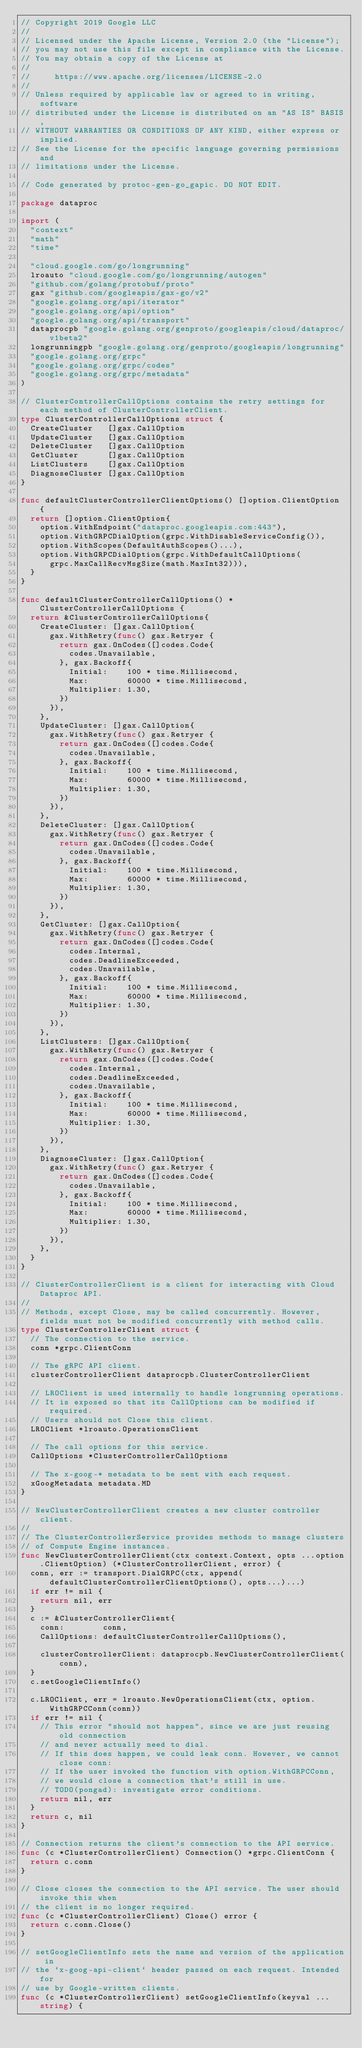Convert code to text. <code><loc_0><loc_0><loc_500><loc_500><_Go_>// Copyright 2019 Google LLC
//
// Licensed under the Apache License, Version 2.0 (the "License");
// you may not use this file except in compliance with the License.
// You may obtain a copy of the License at
//
//     https://www.apache.org/licenses/LICENSE-2.0
//
// Unless required by applicable law or agreed to in writing, software
// distributed under the License is distributed on an "AS IS" BASIS,
// WITHOUT WARRANTIES OR CONDITIONS OF ANY KIND, either express or implied.
// See the License for the specific language governing permissions and
// limitations under the License.

// Code generated by protoc-gen-go_gapic. DO NOT EDIT.

package dataproc

import (
	"context"
	"math"
	"time"

	"cloud.google.com/go/longrunning"
	lroauto "cloud.google.com/go/longrunning/autogen"
	"github.com/golang/protobuf/proto"
	gax "github.com/googleapis/gax-go/v2"
	"google.golang.org/api/iterator"
	"google.golang.org/api/option"
	"google.golang.org/api/transport"
	dataprocpb "google.golang.org/genproto/googleapis/cloud/dataproc/v1beta2"
	longrunningpb "google.golang.org/genproto/googleapis/longrunning"
	"google.golang.org/grpc"
	"google.golang.org/grpc/codes"
	"google.golang.org/grpc/metadata"
)

// ClusterControllerCallOptions contains the retry settings for each method of ClusterControllerClient.
type ClusterControllerCallOptions struct {
	CreateCluster   []gax.CallOption
	UpdateCluster   []gax.CallOption
	DeleteCluster   []gax.CallOption
	GetCluster      []gax.CallOption
	ListClusters    []gax.CallOption
	DiagnoseCluster []gax.CallOption
}

func defaultClusterControllerClientOptions() []option.ClientOption {
	return []option.ClientOption{
		option.WithEndpoint("dataproc.googleapis.com:443"),
		option.WithGRPCDialOption(grpc.WithDisableServiceConfig()),
		option.WithScopes(DefaultAuthScopes()...),
		option.WithGRPCDialOption(grpc.WithDefaultCallOptions(
			grpc.MaxCallRecvMsgSize(math.MaxInt32))),
	}
}

func defaultClusterControllerCallOptions() *ClusterControllerCallOptions {
	return &ClusterControllerCallOptions{
		CreateCluster: []gax.CallOption{
			gax.WithRetry(func() gax.Retryer {
				return gax.OnCodes([]codes.Code{
					codes.Unavailable,
				}, gax.Backoff{
					Initial:    100 * time.Millisecond,
					Max:        60000 * time.Millisecond,
					Multiplier: 1.30,
				})
			}),
		},
		UpdateCluster: []gax.CallOption{
			gax.WithRetry(func() gax.Retryer {
				return gax.OnCodes([]codes.Code{
					codes.Unavailable,
				}, gax.Backoff{
					Initial:    100 * time.Millisecond,
					Max:        60000 * time.Millisecond,
					Multiplier: 1.30,
				})
			}),
		},
		DeleteCluster: []gax.CallOption{
			gax.WithRetry(func() gax.Retryer {
				return gax.OnCodes([]codes.Code{
					codes.Unavailable,
				}, gax.Backoff{
					Initial:    100 * time.Millisecond,
					Max:        60000 * time.Millisecond,
					Multiplier: 1.30,
				})
			}),
		},
		GetCluster: []gax.CallOption{
			gax.WithRetry(func() gax.Retryer {
				return gax.OnCodes([]codes.Code{
					codes.Internal,
					codes.DeadlineExceeded,
					codes.Unavailable,
				}, gax.Backoff{
					Initial:    100 * time.Millisecond,
					Max:        60000 * time.Millisecond,
					Multiplier: 1.30,
				})
			}),
		},
		ListClusters: []gax.CallOption{
			gax.WithRetry(func() gax.Retryer {
				return gax.OnCodes([]codes.Code{
					codes.Internal,
					codes.DeadlineExceeded,
					codes.Unavailable,
				}, gax.Backoff{
					Initial:    100 * time.Millisecond,
					Max:        60000 * time.Millisecond,
					Multiplier: 1.30,
				})
			}),
		},
		DiagnoseCluster: []gax.CallOption{
			gax.WithRetry(func() gax.Retryer {
				return gax.OnCodes([]codes.Code{
					codes.Unavailable,
				}, gax.Backoff{
					Initial:    100 * time.Millisecond,
					Max:        60000 * time.Millisecond,
					Multiplier: 1.30,
				})
			}),
		},
	}
}

// ClusterControllerClient is a client for interacting with Cloud Dataproc API.
//
// Methods, except Close, may be called concurrently. However, fields must not be modified concurrently with method calls.
type ClusterControllerClient struct {
	// The connection to the service.
	conn *grpc.ClientConn

	// The gRPC API client.
	clusterControllerClient dataprocpb.ClusterControllerClient

	// LROClient is used internally to handle longrunning operations.
	// It is exposed so that its CallOptions can be modified if required.
	// Users should not Close this client.
	LROClient *lroauto.OperationsClient

	// The call options for this service.
	CallOptions *ClusterControllerCallOptions

	// The x-goog-* metadata to be sent with each request.
	xGoogMetadata metadata.MD
}

// NewClusterControllerClient creates a new cluster controller client.
//
// The ClusterControllerService provides methods to manage clusters
// of Compute Engine instances.
func NewClusterControllerClient(ctx context.Context, opts ...option.ClientOption) (*ClusterControllerClient, error) {
	conn, err := transport.DialGRPC(ctx, append(defaultClusterControllerClientOptions(), opts...)...)
	if err != nil {
		return nil, err
	}
	c := &ClusterControllerClient{
		conn:        conn,
		CallOptions: defaultClusterControllerCallOptions(),

		clusterControllerClient: dataprocpb.NewClusterControllerClient(conn),
	}
	c.setGoogleClientInfo()

	c.LROClient, err = lroauto.NewOperationsClient(ctx, option.WithGRPCConn(conn))
	if err != nil {
		// This error "should not happen", since we are just reusing old connection
		// and never actually need to dial.
		// If this does happen, we could leak conn. However, we cannot close conn:
		// If the user invoked the function with option.WithGRPCConn,
		// we would close a connection that's still in use.
		// TODO(pongad): investigate error conditions.
		return nil, err
	}
	return c, nil
}

// Connection returns the client's connection to the API service.
func (c *ClusterControllerClient) Connection() *grpc.ClientConn {
	return c.conn
}

// Close closes the connection to the API service. The user should invoke this when
// the client is no longer required.
func (c *ClusterControllerClient) Close() error {
	return c.conn.Close()
}

// setGoogleClientInfo sets the name and version of the application in
// the `x-goog-api-client` header passed on each request. Intended for
// use by Google-written clients.
func (c *ClusterControllerClient) setGoogleClientInfo(keyval ...string) {</code> 